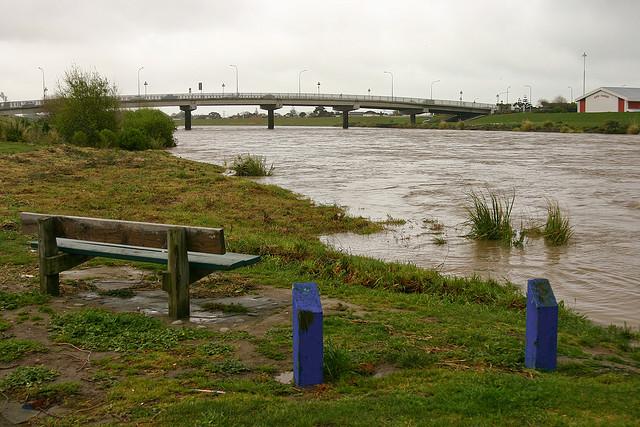Is this a river?
Answer briefly. Yes. How many light post are there?
Quick response, please. 0. Does the water flow?
Keep it brief. Yes. Is it flooded?
Quick response, please. Yes. Is it winter?
Be succinct. No. Where is the bird?
Short answer required. Nowhere. Is this photo filtered?
Quick response, please. No. What will be passing under the bridge?
Concise answer only. Water. Who is sitting on the bench?
Be succinct. No one. 